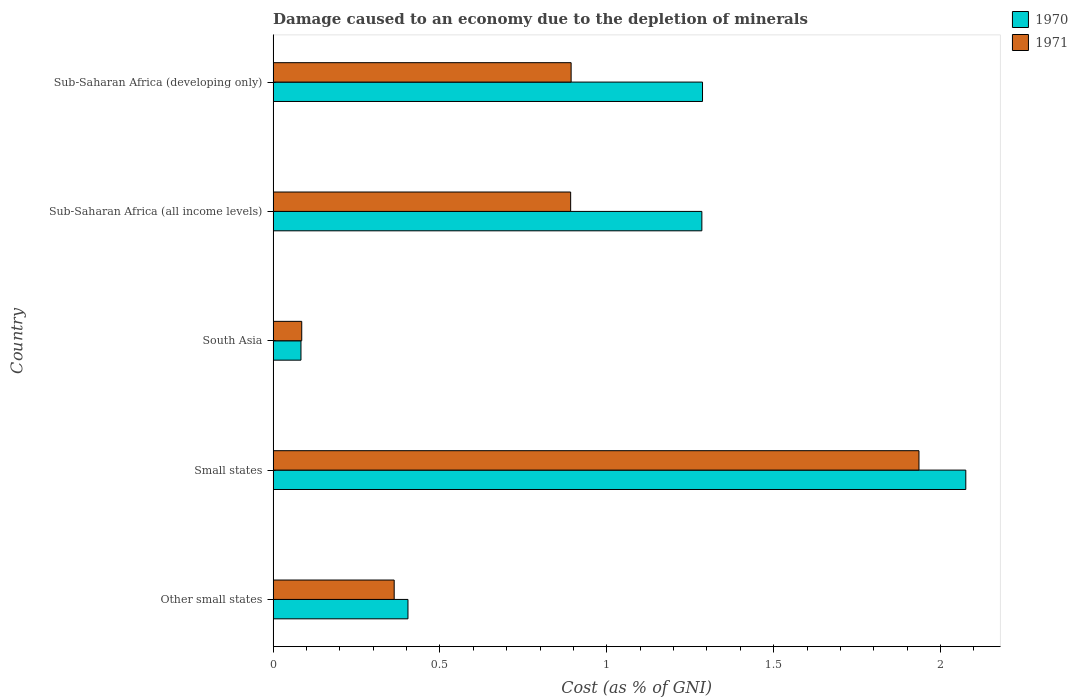Are the number of bars on each tick of the Y-axis equal?
Provide a succinct answer. Yes. How many bars are there on the 4th tick from the bottom?
Keep it short and to the point. 2. What is the label of the 4th group of bars from the top?
Your answer should be very brief. Small states. What is the cost of damage caused due to the depletion of minerals in 1971 in Other small states?
Offer a terse response. 0.36. Across all countries, what is the maximum cost of damage caused due to the depletion of minerals in 1971?
Keep it short and to the point. 1.94. Across all countries, what is the minimum cost of damage caused due to the depletion of minerals in 1971?
Ensure brevity in your answer.  0.09. In which country was the cost of damage caused due to the depletion of minerals in 1971 maximum?
Your response must be concise. Small states. What is the total cost of damage caused due to the depletion of minerals in 1970 in the graph?
Give a very brief answer. 5.13. What is the difference between the cost of damage caused due to the depletion of minerals in 1971 in Small states and that in Sub-Saharan Africa (all income levels)?
Provide a succinct answer. 1.04. What is the difference between the cost of damage caused due to the depletion of minerals in 1970 in South Asia and the cost of damage caused due to the depletion of minerals in 1971 in Small states?
Offer a very short reply. -1.85. What is the average cost of damage caused due to the depletion of minerals in 1970 per country?
Make the answer very short. 1.03. What is the difference between the cost of damage caused due to the depletion of minerals in 1970 and cost of damage caused due to the depletion of minerals in 1971 in Other small states?
Provide a succinct answer. 0.04. In how many countries, is the cost of damage caused due to the depletion of minerals in 1970 greater than 1.1 %?
Give a very brief answer. 3. What is the ratio of the cost of damage caused due to the depletion of minerals in 1971 in Small states to that in Sub-Saharan Africa (developing only)?
Provide a succinct answer. 2.17. Is the cost of damage caused due to the depletion of minerals in 1970 in Small states less than that in South Asia?
Offer a terse response. No. What is the difference between the highest and the second highest cost of damage caused due to the depletion of minerals in 1970?
Offer a very short reply. 0.79. What is the difference between the highest and the lowest cost of damage caused due to the depletion of minerals in 1970?
Offer a very short reply. 1.99. In how many countries, is the cost of damage caused due to the depletion of minerals in 1970 greater than the average cost of damage caused due to the depletion of minerals in 1970 taken over all countries?
Offer a terse response. 3. What does the 1st bar from the top in Small states represents?
Provide a short and direct response. 1971. How many countries are there in the graph?
Keep it short and to the point. 5. Does the graph contain grids?
Your answer should be compact. No. How many legend labels are there?
Offer a very short reply. 2. How are the legend labels stacked?
Your answer should be very brief. Vertical. What is the title of the graph?
Provide a succinct answer. Damage caused to an economy due to the depletion of minerals. What is the label or title of the X-axis?
Offer a very short reply. Cost (as % of GNI). What is the Cost (as % of GNI) of 1970 in Other small states?
Your answer should be very brief. 0.4. What is the Cost (as % of GNI) in 1971 in Other small states?
Keep it short and to the point. 0.36. What is the Cost (as % of GNI) in 1970 in Small states?
Your answer should be compact. 2.08. What is the Cost (as % of GNI) in 1971 in Small states?
Offer a terse response. 1.94. What is the Cost (as % of GNI) of 1970 in South Asia?
Provide a succinct answer. 0.08. What is the Cost (as % of GNI) in 1971 in South Asia?
Provide a short and direct response. 0.09. What is the Cost (as % of GNI) in 1970 in Sub-Saharan Africa (all income levels)?
Offer a terse response. 1.28. What is the Cost (as % of GNI) of 1971 in Sub-Saharan Africa (all income levels)?
Make the answer very short. 0.89. What is the Cost (as % of GNI) of 1970 in Sub-Saharan Africa (developing only)?
Provide a succinct answer. 1.29. What is the Cost (as % of GNI) of 1971 in Sub-Saharan Africa (developing only)?
Offer a terse response. 0.89. Across all countries, what is the maximum Cost (as % of GNI) in 1970?
Offer a terse response. 2.08. Across all countries, what is the maximum Cost (as % of GNI) in 1971?
Your response must be concise. 1.94. Across all countries, what is the minimum Cost (as % of GNI) of 1970?
Your answer should be compact. 0.08. Across all countries, what is the minimum Cost (as % of GNI) of 1971?
Your answer should be compact. 0.09. What is the total Cost (as % of GNI) in 1970 in the graph?
Offer a terse response. 5.13. What is the total Cost (as % of GNI) of 1971 in the graph?
Keep it short and to the point. 4.17. What is the difference between the Cost (as % of GNI) of 1970 in Other small states and that in Small states?
Provide a short and direct response. -1.67. What is the difference between the Cost (as % of GNI) in 1971 in Other small states and that in Small states?
Provide a short and direct response. -1.57. What is the difference between the Cost (as % of GNI) of 1970 in Other small states and that in South Asia?
Provide a succinct answer. 0.32. What is the difference between the Cost (as % of GNI) of 1971 in Other small states and that in South Asia?
Provide a short and direct response. 0.28. What is the difference between the Cost (as % of GNI) in 1970 in Other small states and that in Sub-Saharan Africa (all income levels)?
Your answer should be compact. -0.88. What is the difference between the Cost (as % of GNI) of 1971 in Other small states and that in Sub-Saharan Africa (all income levels)?
Provide a succinct answer. -0.53. What is the difference between the Cost (as % of GNI) in 1970 in Other small states and that in Sub-Saharan Africa (developing only)?
Keep it short and to the point. -0.88. What is the difference between the Cost (as % of GNI) of 1971 in Other small states and that in Sub-Saharan Africa (developing only)?
Make the answer very short. -0.53. What is the difference between the Cost (as % of GNI) in 1970 in Small states and that in South Asia?
Ensure brevity in your answer.  1.99. What is the difference between the Cost (as % of GNI) of 1971 in Small states and that in South Asia?
Keep it short and to the point. 1.85. What is the difference between the Cost (as % of GNI) in 1970 in Small states and that in Sub-Saharan Africa (all income levels)?
Give a very brief answer. 0.79. What is the difference between the Cost (as % of GNI) of 1971 in Small states and that in Sub-Saharan Africa (all income levels)?
Provide a succinct answer. 1.04. What is the difference between the Cost (as % of GNI) of 1970 in Small states and that in Sub-Saharan Africa (developing only)?
Give a very brief answer. 0.79. What is the difference between the Cost (as % of GNI) of 1971 in Small states and that in Sub-Saharan Africa (developing only)?
Provide a succinct answer. 1.04. What is the difference between the Cost (as % of GNI) in 1970 in South Asia and that in Sub-Saharan Africa (all income levels)?
Your response must be concise. -1.2. What is the difference between the Cost (as % of GNI) in 1971 in South Asia and that in Sub-Saharan Africa (all income levels)?
Keep it short and to the point. -0.81. What is the difference between the Cost (as % of GNI) in 1970 in South Asia and that in Sub-Saharan Africa (developing only)?
Give a very brief answer. -1.2. What is the difference between the Cost (as % of GNI) in 1971 in South Asia and that in Sub-Saharan Africa (developing only)?
Offer a terse response. -0.81. What is the difference between the Cost (as % of GNI) of 1970 in Sub-Saharan Africa (all income levels) and that in Sub-Saharan Africa (developing only)?
Provide a succinct answer. -0. What is the difference between the Cost (as % of GNI) of 1971 in Sub-Saharan Africa (all income levels) and that in Sub-Saharan Africa (developing only)?
Give a very brief answer. -0. What is the difference between the Cost (as % of GNI) in 1970 in Other small states and the Cost (as % of GNI) in 1971 in Small states?
Provide a short and direct response. -1.53. What is the difference between the Cost (as % of GNI) of 1970 in Other small states and the Cost (as % of GNI) of 1971 in South Asia?
Make the answer very short. 0.32. What is the difference between the Cost (as % of GNI) of 1970 in Other small states and the Cost (as % of GNI) of 1971 in Sub-Saharan Africa (all income levels)?
Make the answer very short. -0.49. What is the difference between the Cost (as % of GNI) of 1970 in Other small states and the Cost (as % of GNI) of 1971 in Sub-Saharan Africa (developing only)?
Make the answer very short. -0.49. What is the difference between the Cost (as % of GNI) of 1970 in Small states and the Cost (as % of GNI) of 1971 in South Asia?
Provide a succinct answer. 1.99. What is the difference between the Cost (as % of GNI) in 1970 in Small states and the Cost (as % of GNI) in 1971 in Sub-Saharan Africa (all income levels)?
Keep it short and to the point. 1.18. What is the difference between the Cost (as % of GNI) in 1970 in Small states and the Cost (as % of GNI) in 1971 in Sub-Saharan Africa (developing only)?
Provide a succinct answer. 1.18. What is the difference between the Cost (as % of GNI) in 1970 in South Asia and the Cost (as % of GNI) in 1971 in Sub-Saharan Africa (all income levels)?
Give a very brief answer. -0.81. What is the difference between the Cost (as % of GNI) in 1970 in South Asia and the Cost (as % of GNI) in 1971 in Sub-Saharan Africa (developing only)?
Your answer should be compact. -0.81. What is the difference between the Cost (as % of GNI) in 1970 in Sub-Saharan Africa (all income levels) and the Cost (as % of GNI) in 1971 in Sub-Saharan Africa (developing only)?
Offer a terse response. 0.39. What is the average Cost (as % of GNI) of 1971 per country?
Give a very brief answer. 0.83. What is the difference between the Cost (as % of GNI) of 1970 and Cost (as % of GNI) of 1971 in Other small states?
Provide a short and direct response. 0.04. What is the difference between the Cost (as % of GNI) in 1970 and Cost (as % of GNI) in 1971 in Small states?
Offer a terse response. 0.14. What is the difference between the Cost (as % of GNI) of 1970 and Cost (as % of GNI) of 1971 in South Asia?
Your answer should be compact. -0. What is the difference between the Cost (as % of GNI) of 1970 and Cost (as % of GNI) of 1971 in Sub-Saharan Africa (all income levels)?
Provide a succinct answer. 0.39. What is the difference between the Cost (as % of GNI) in 1970 and Cost (as % of GNI) in 1971 in Sub-Saharan Africa (developing only)?
Your answer should be compact. 0.39. What is the ratio of the Cost (as % of GNI) of 1970 in Other small states to that in Small states?
Offer a terse response. 0.19. What is the ratio of the Cost (as % of GNI) in 1971 in Other small states to that in Small states?
Offer a very short reply. 0.19. What is the ratio of the Cost (as % of GNI) in 1970 in Other small states to that in South Asia?
Offer a very short reply. 4.84. What is the ratio of the Cost (as % of GNI) in 1971 in Other small states to that in South Asia?
Your response must be concise. 4.23. What is the ratio of the Cost (as % of GNI) of 1970 in Other small states to that in Sub-Saharan Africa (all income levels)?
Provide a short and direct response. 0.31. What is the ratio of the Cost (as % of GNI) of 1971 in Other small states to that in Sub-Saharan Africa (all income levels)?
Offer a very short reply. 0.41. What is the ratio of the Cost (as % of GNI) of 1970 in Other small states to that in Sub-Saharan Africa (developing only)?
Your response must be concise. 0.31. What is the ratio of the Cost (as % of GNI) of 1971 in Other small states to that in Sub-Saharan Africa (developing only)?
Give a very brief answer. 0.41. What is the ratio of the Cost (as % of GNI) of 1970 in Small states to that in South Asia?
Give a very brief answer. 24.88. What is the ratio of the Cost (as % of GNI) of 1971 in Small states to that in South Asia?
Provide a short and direct response. 22.57. What is the ratio of the Cost (as % of GNI) of 1970 in Small states to that in Sub-Saharan Africa (all income levels)?
Provide a succinct answer. 1.62. What is the ratio of the Cost (as % of GNI) in 1971 in Small states to that in Sub-Saharan Africa (all income levels)?
Give a very brief answer. 2.17. What is the ratio of the Cost (as % of GNI) in 1970 in Small states to that in Sub-Saharan Africa (developing only)?
Ensure brevity in your answer.  1.61. What is the ratio of the Cost (as % of GNI) of 1971 in Small states to that in Sub-Saharan Africa (developing only)?
Your answer should be compact. 2.17. What is the ratio of the Cost (as % of GNI) in 1970 in South Asia to that in Sub-Saharan Africa (all income levels)?
Keep it short and to the point. 0.06. What is the ratio of the Cost (as % of GNI) of 1971 in South Asia to that in Sub-Saharan Africa (all income levels)?
Provide a short and direct response. 0.1. What is the ratio of the Cost (as % of GNI) of 1970 in South Asia to that in Sub-Saharan Africa (developing only)?
Make the answer very short. 0.06. What is the ratio of the Cost (as % of GNI) of 1971 in South Asia to that in Sub-Saharan Africa (developing only)?
Provide a short and direct response. 0.1. What is the difference between the highest and the second highest Cost (as % of GNI) of 1970?
Your answer should be very brief. 0.79. What is the difference between the highest and the second highest Cost (as % of GNI) of 1971?
Give a very brief answer. 1.04. What is the difference between the highest and the lowest Cost (as % of GNI) in 1970?
Offer a terse response. 1.99. What is the difference between the highest and the lowest Cost (as % of GNI) in 1971?
Keep it short and to the point. 1.85. 